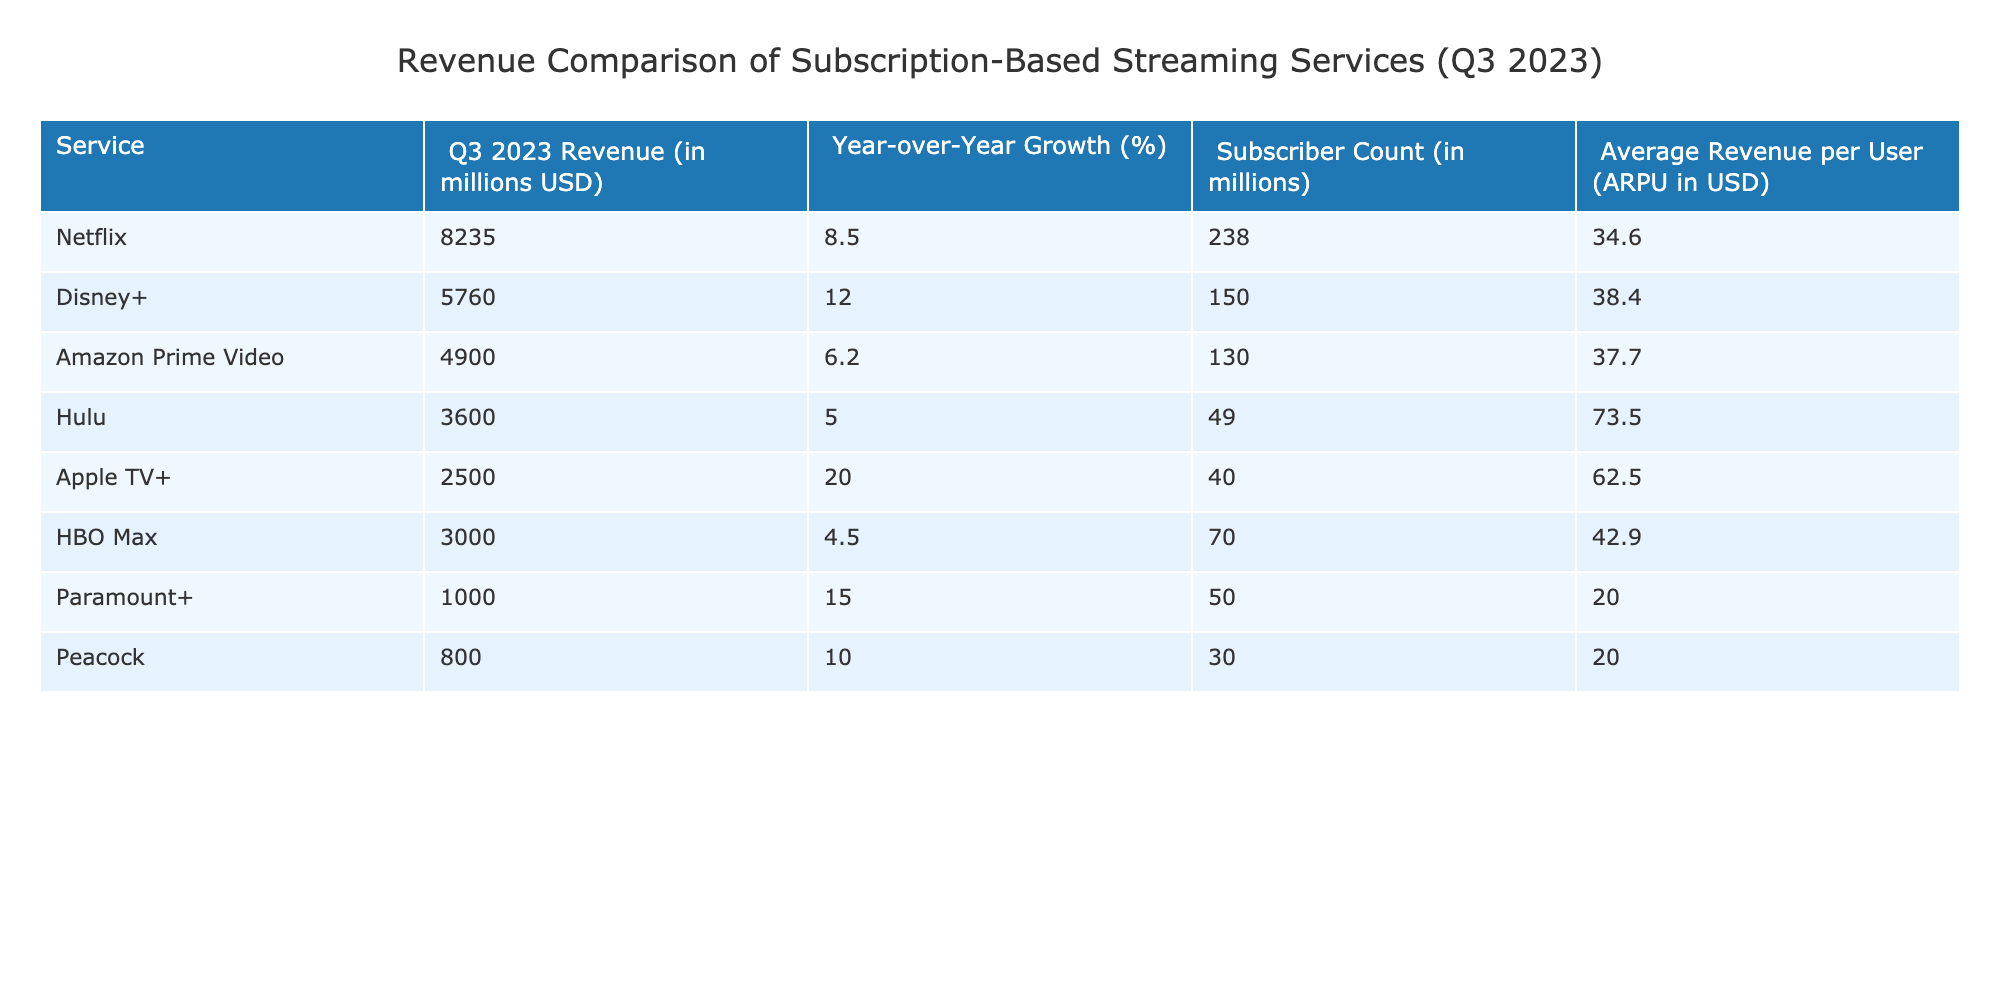What was Netflix's Q3 2023 revenue? The table shows that Netflix generated a revenue of 8235 million USD in Q3 2023.
Answer: 8235 million USD Which streaming service had the highest Year-over-Year Growth? By comparing the "Year-over-Year Growth (%)" column, Apple TV+ had the highest growth at 20.0%.
Answer: Apple TV+ What is the Average Revenue per User (ARPU) of Hulu? The ARPU for Hulu, as indicated in the table, is 73.5 USD.
Answer: 73.5 USD Calculate the total revenue of Disney+, Amazon Prime Video, and Netflix combined. The total revenue for these services can be calculated as follows: 5760 + 4900 + 8235 = 18895 million USD.
Answer: 18895 million USD Is it true that Paramount+ has a higher subscriber count than Peacock? From the table, Paramount+ has 50 million subscribers while Peacock has 30 million. Therefore, the statement is true.
Answer: Yes What is the difference in revenue between Apple TV+ and HBO Max? The revenue for Apple TV+ is 2500 million USD and for HBO Max is 3000 million USD. The difference is 3000 - 2500 = 500 million USD.
Answer: 500 million USD Which service has the lowest Average Revenue per User (ARPU)? Examining the ARPU values, Paramount+ has the lowest ARPU at 20.0 USD.
Answer: 20.0 USD If you were to list the services in order of their subscriber count from highest to lowest, who would be in the second position? By referring to the "Subscriber Count" column, the order would be: Netflix (238), Disney+ (150), Amazon Prime Video (130). Hence, Amazon Prime Video is second in position.
Answer: Amazon Prime Video Did any streaming service experience a Year-over-Year Growth of over 10% in Q3 2023? Looking at the "Year-over-Year Growth (%)" column, both Disney+ (12.0%) and Apple TV+ (20.0%) meet this criterion. Therefore, the answer is yes.
Answer: Yes 